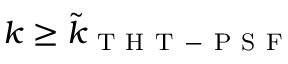Convert formula to latex. <formula><loc_0><loc_0><loc_500><loc_500>k \geq \tilde { k } _ { T H T - P S F }</formula> 